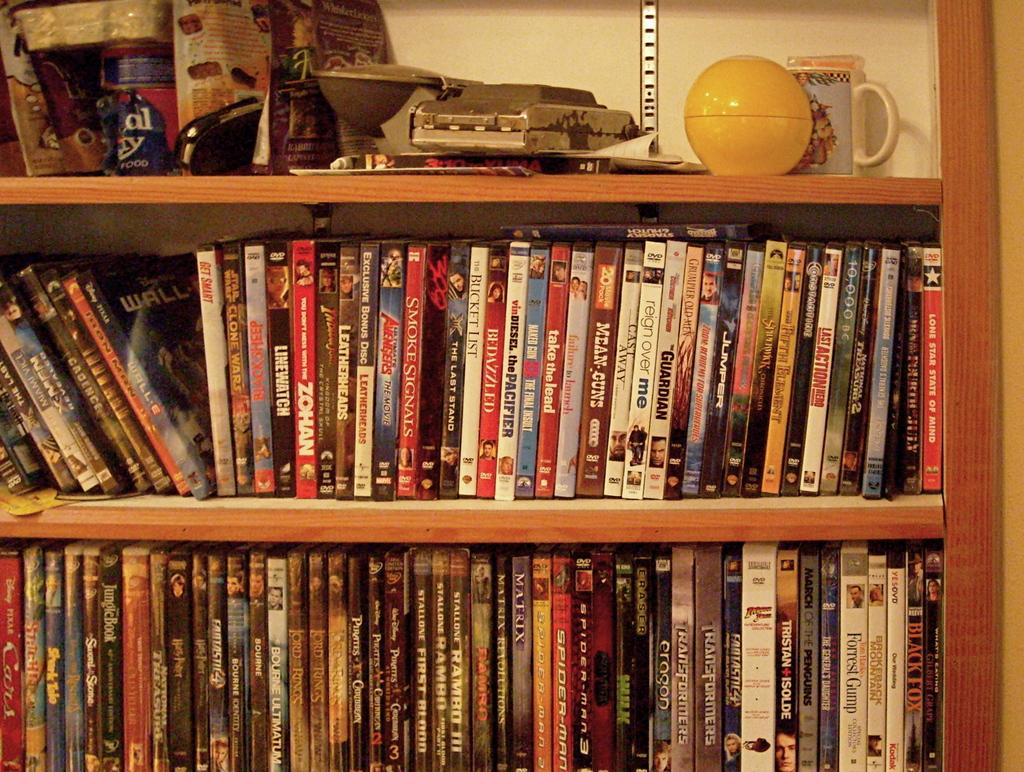<image>
Create a compact narrative representing the image presented. Numerous DVDs, including titles like Wall-E, Bedazzled and Bucket List, fill the shelves of a bookcase. 